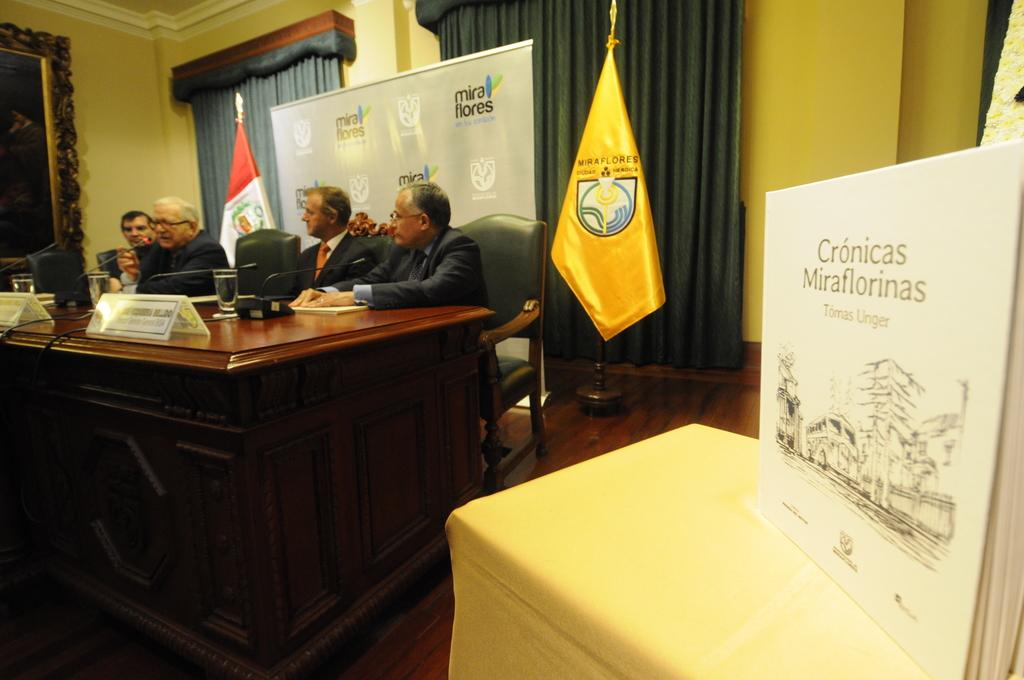What are the persons in the image doing? The persons in the image are sitting on chairs. Where are the chairs located in relation to the desk? The chairs are near a desk. What can be seen on the desk? There is a glass object on the desk. What type of window treatment is present in the image? Curtains are present in the image. What is the flag associated with in the image? The flag is present in the image. What is hanging on the wall in the image? A poster is visible in the image. What type of structure is present in the image? There is a wall in the image. What type of frame is present in the image? A frame is present in the image. What type of silk is being used for the operation in the image? There is no operation or silk present in the image. How does the person in the image say good-bye to their friends? There is no indication of a good-bye or friends in the image. 